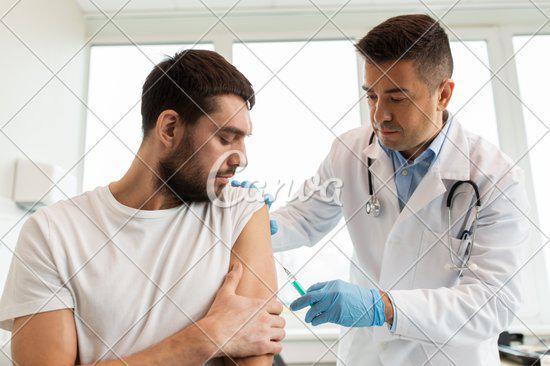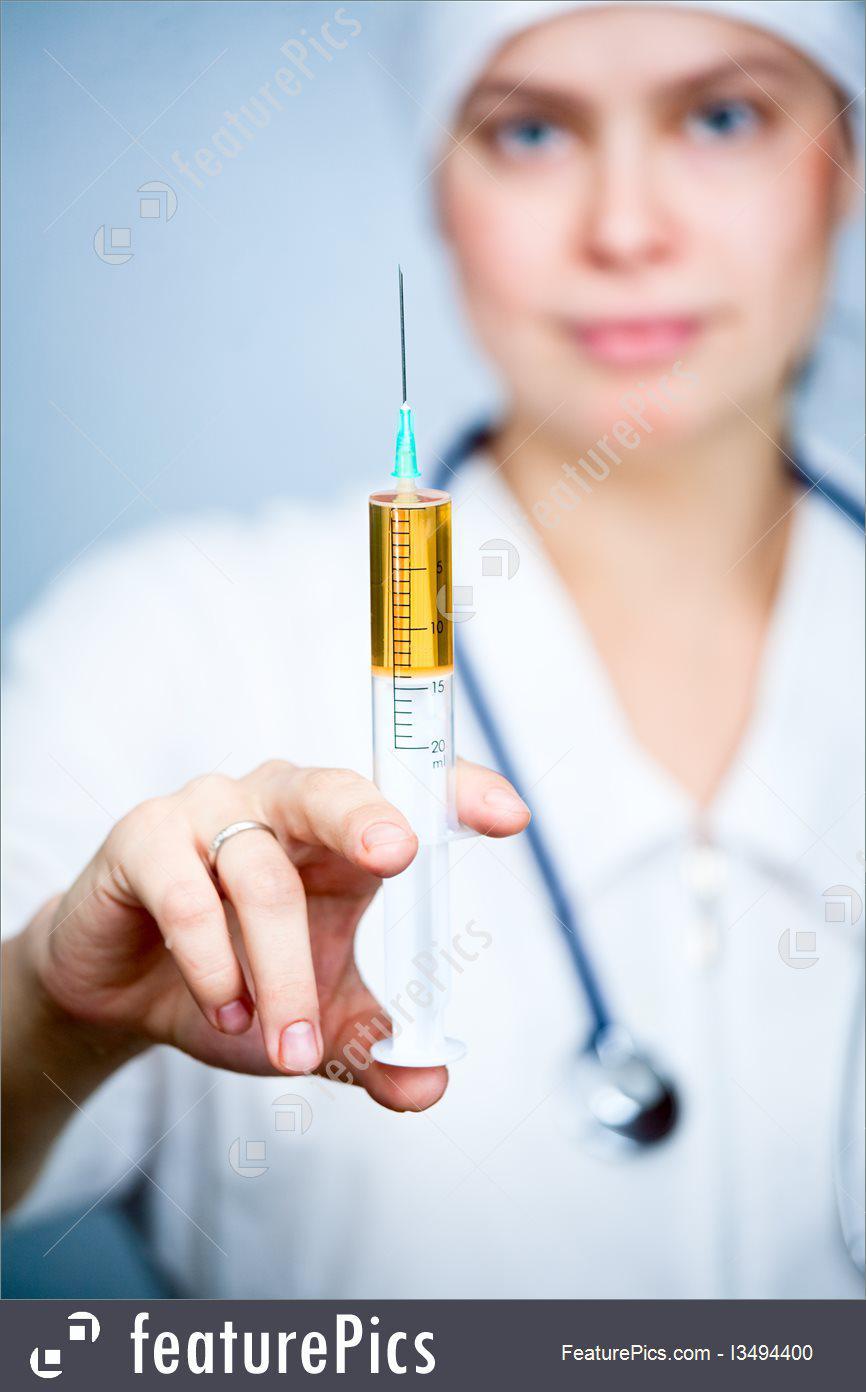The first image is the image on the left, the second image is the image on the right. For the images shown, is this caption "The left and right image contains a total of two woman holding needles." true? Answer yes or no. No. The first image is the image on the left, the second image is the image on the right. Analyze the images presented: Is the assertion "The right image shows a forward-facing woman with a bare neck and white shirt holding up a syringe of yellow liquid." valid? Answer yes or no. Yes. 